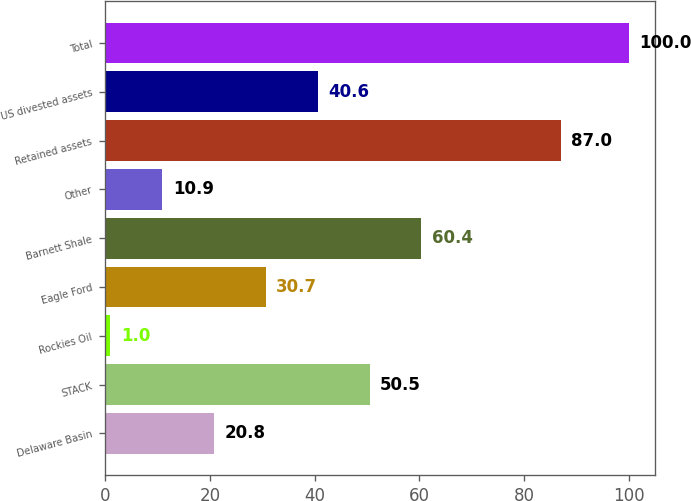Convert chart to OTSL. <chart><loc_0><loc_0><loc_500><loc_500><bar_chart><fcel>Delaware Basin<fcel>STACK<fcel>Rockies Oil<fcel>Eagle Ford<fcel>Barnett Shale<fcel>Other<fcel>Retained assets<fcel>US divested assets<fcel>Total<nl><fcel>20.8<fcel>50.5<fcel>1<fcel>30.7<fcel>60.4<fcel>10.9<fcel>87<fcel>40.6<fcel>100<nl></chart> 